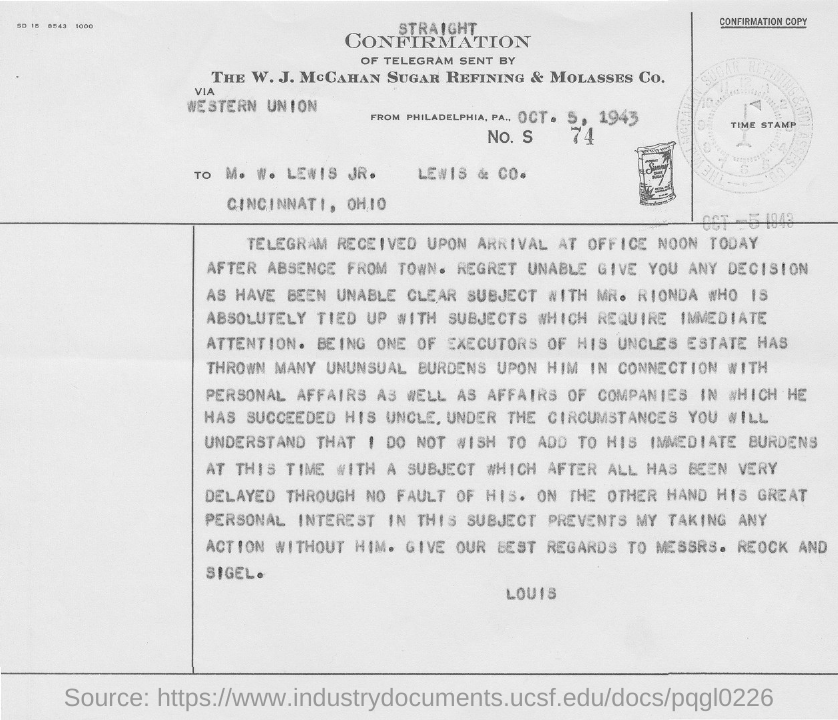Specify some key components in this picture. I request that 'Give best regards to Messrs. Reock and Sigel' be declared. The letter is addressed to M. W. Lewis Jr. 